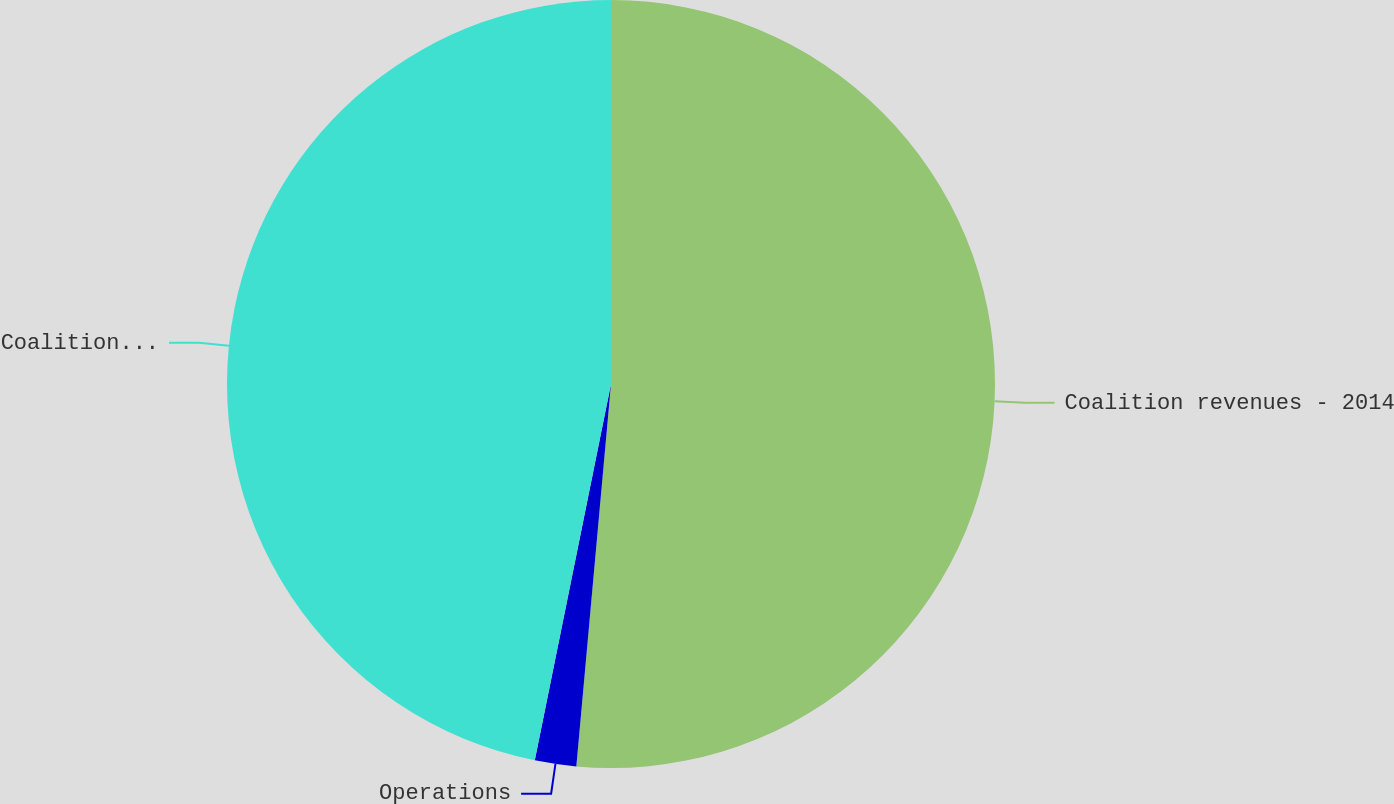Convert chart to OTSL. <chart><loc_0><loc_0><loc_500><loc_500><pie_chart><fcel>Coalition revenues - 2014<fcel>Operations<fcel>Coalition revenues - 2016<nl><fcel>51.44%<fcel>1.74%<fcel>46.82%<nl></chart> 